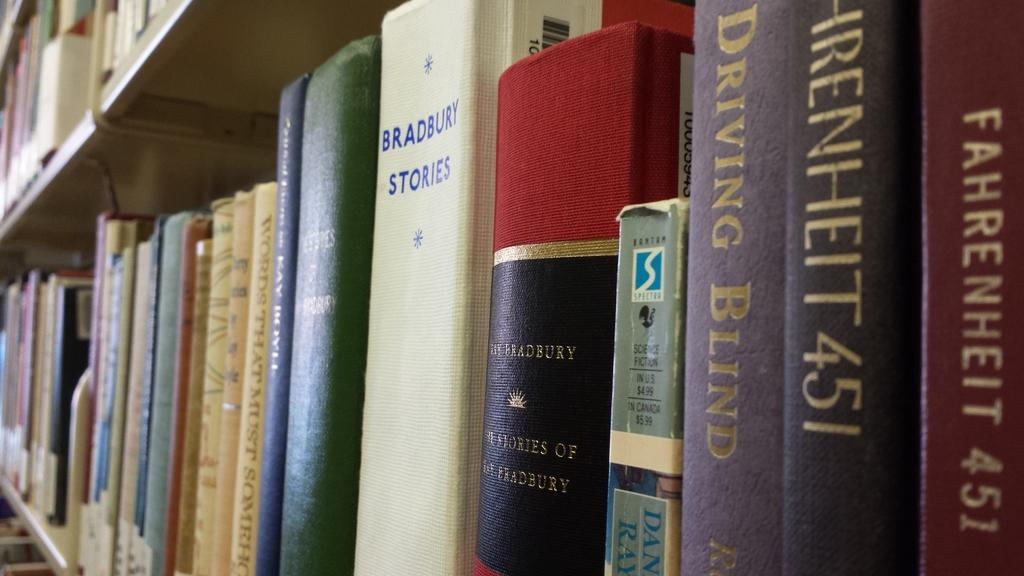<image>
Describe the image concisely. A row of books with titles such as Farenheit 451 and Bradbury Stories. 